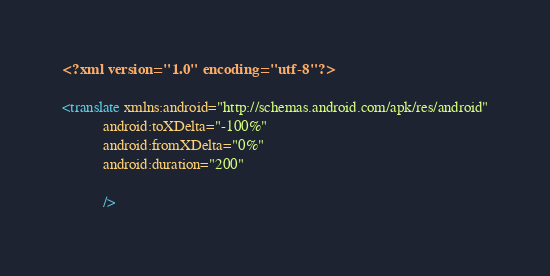<code> <loc_0><loc_0><loc_500><loc_500><_XML_><?xml version="1.0" encoding="utf-8"?>
    
<translate xmlns:android="http://schemas.android.com/apk/res/android"
           android:toXDelta="-100%"
           android:fromXDelta="0%"
           android:duration="200" 
           
           />
</code> 